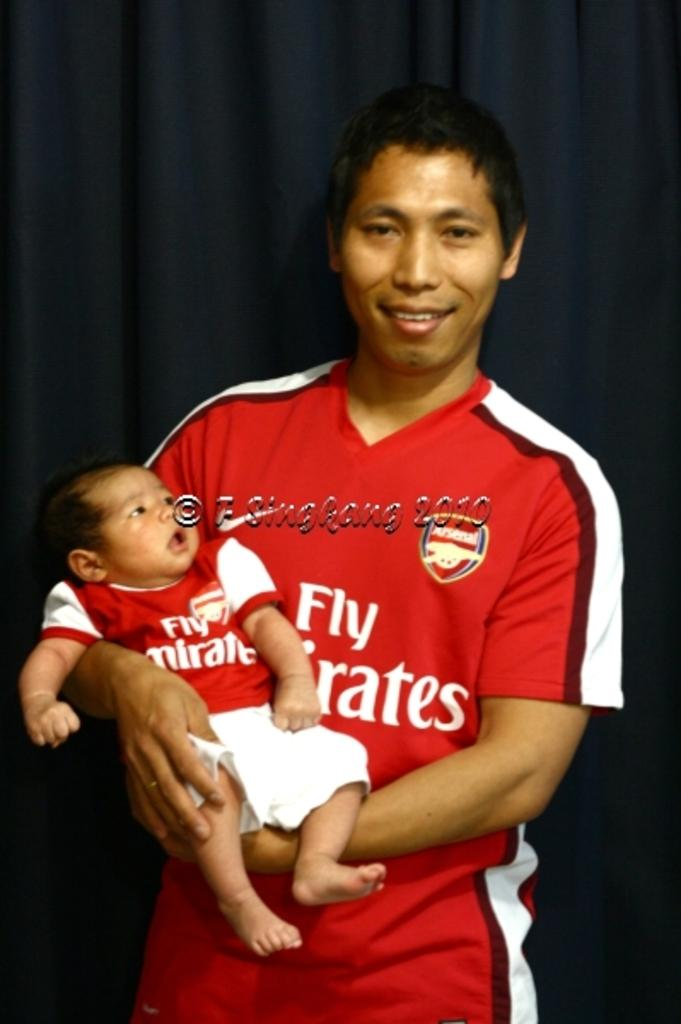<image>
Offer a succinct explanation of the picture presented. A man holding a baby and they're both wearing Fly Emirates shirts. 